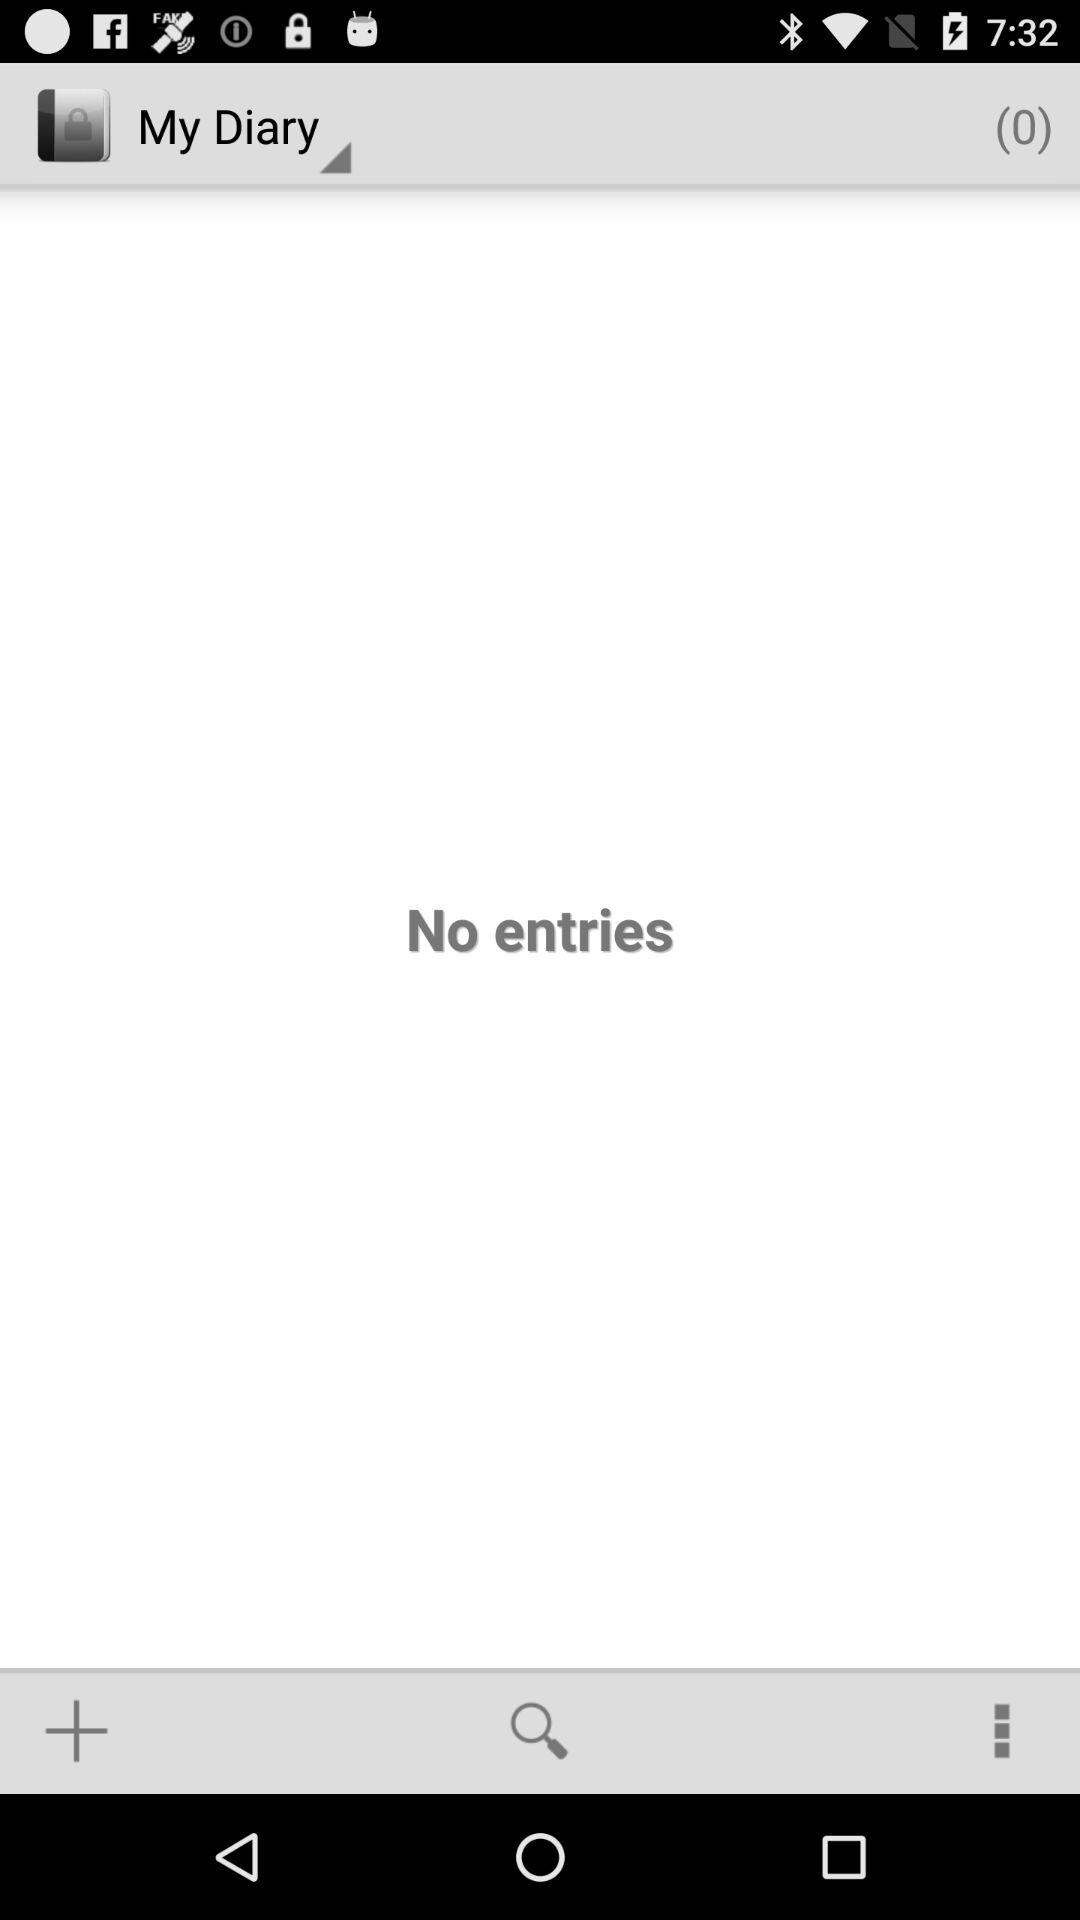How many entries are there in the diary?
Answer the question using a single word or phrase. 0 